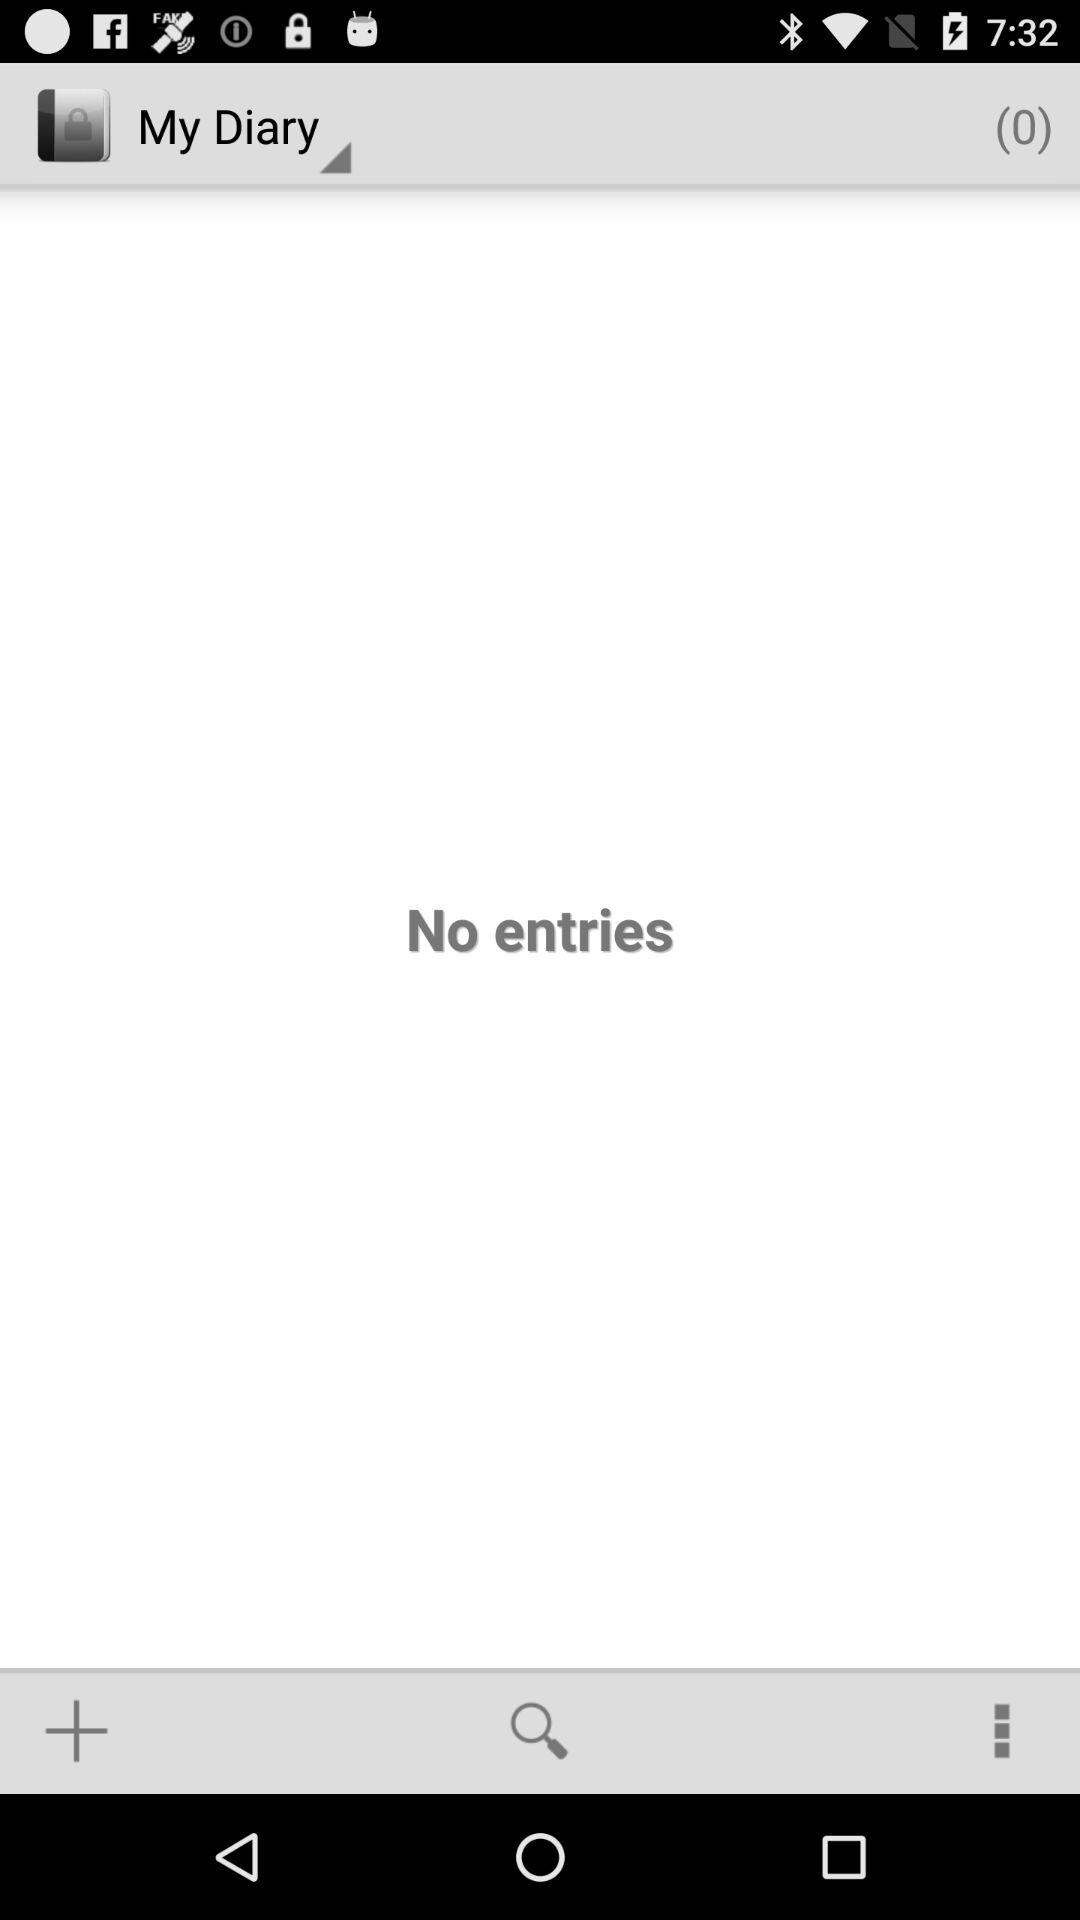How many entries are there in the diary?
Answer the question using a single word or phrase. 0 